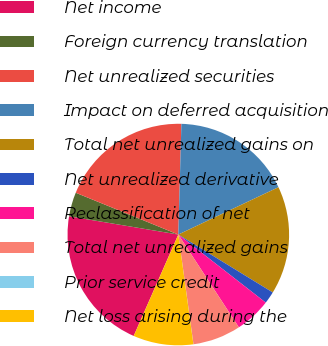<chart> <loc_0><loc_0><loc_500><loc_500><pie_chart><fcel>Net income<fcel>Foreign currency translation<fcel>Net unrealized securities<fcel>Impact on deferred acquisition<fcel>Total net unrealized gains on<fcel>Net unrealized derivative<fcel>Reclassification of net<fcel>Total net unrealized gains<fcel>Prior service credit<fcel>Net loss arising during the<nl><fcel>21.04%<fcel>3.52%<fcel>19.28%<fcel>17.53%<fcel>15.78%<fcel>1.77%<fcel>5.27%<fcel>7.02%<fcel>0.01%<fcel>8.77%<nl></chart> 